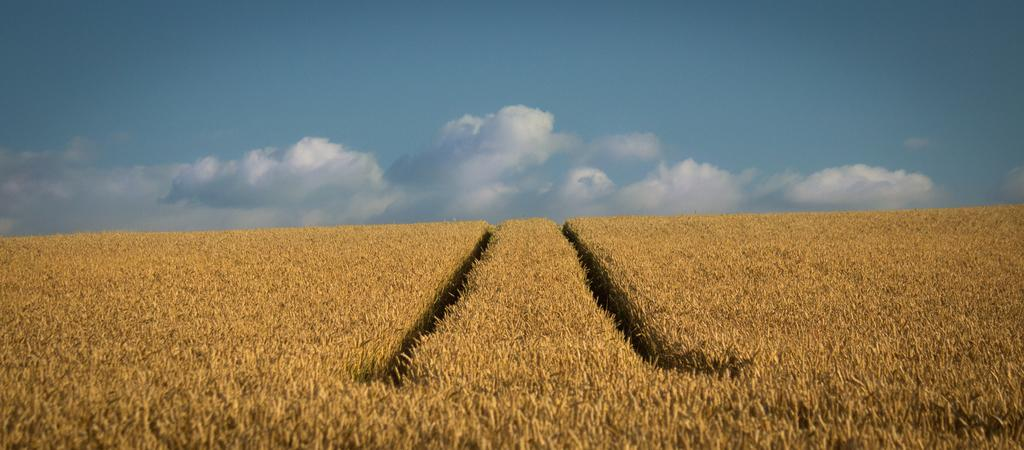What type of landscape is depicted in the image? There is a field in the image. What can be seen in the sky in the image? There are clouds in the sky in the image. What is the rate of the engine in the image? There is no engine present in the image, so it is not possible to determine the rate. 